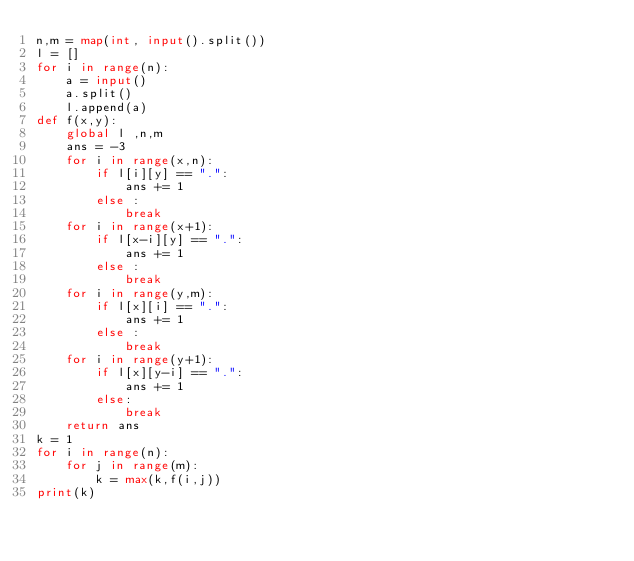<code> <loc_0><loc_0><loc_500><loc_500><_Python_>n,m = map(int, input().split())
l = []
for i in range(n):
    a = input()
    a.split()
    l.append(a)
def f(x,y):
    global l ,n,m
    ans = -3
    for i in range(x,n):
        if l[i][y] == ".":
            ans += 1
        else :
            break
    for i in range(x+1):
        if l[x-i][y] == ".":
            ans += 1
        else :
            break
    for i in range(y,m):
        if l[x][i] == ".":
            ans += 1
        else :
            break
    for i in range(y+1):
        if l[x][y-i] == ".":
            ans += 1
        else:
            break
    return ans
k = 1
for i in range(n):
    for j in range(m):
        k = max(k,f(i,j))
print(k)
</code> 